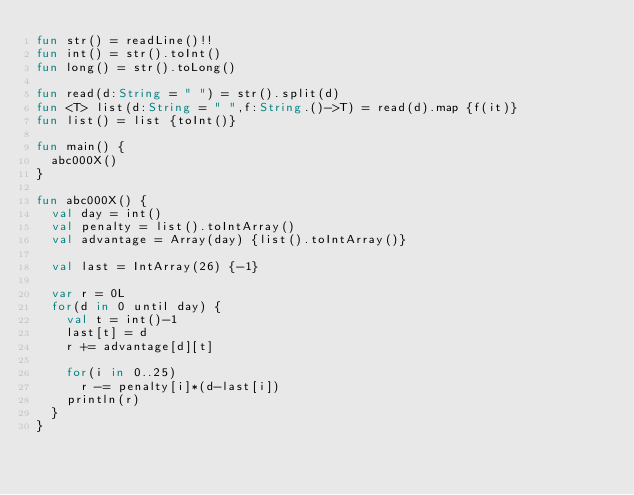<code> <loc_0><loc_0><loc_500><loc_500><_Kotlin_>fun str() = readLine()!!
fun int() = str().toInt()
fun long() = str().toLong()

fun read(d:String = " ") = str().split(d)
fun <T> list(d:String = " ",f:String.()->T) = read(d).map {f(it)}
fun list() = list {toInt()}

fun main() {
	abc000X()
}

fun abc000X() {
	val day = int()
	val penalty = list().toIntArray()
	val advantage = Array(day) {list().toIntArray()}

	val last = IntArray(26) {-1}

	var r = 0L
	for(d in 0 until day) {
		val t = int()-1
		last[t] = d
		r += advantage[d][t]

		for(i in 0..25)
			r -= penalty[i]*(d-last[i])
		println(r)
	}
}
</code> 